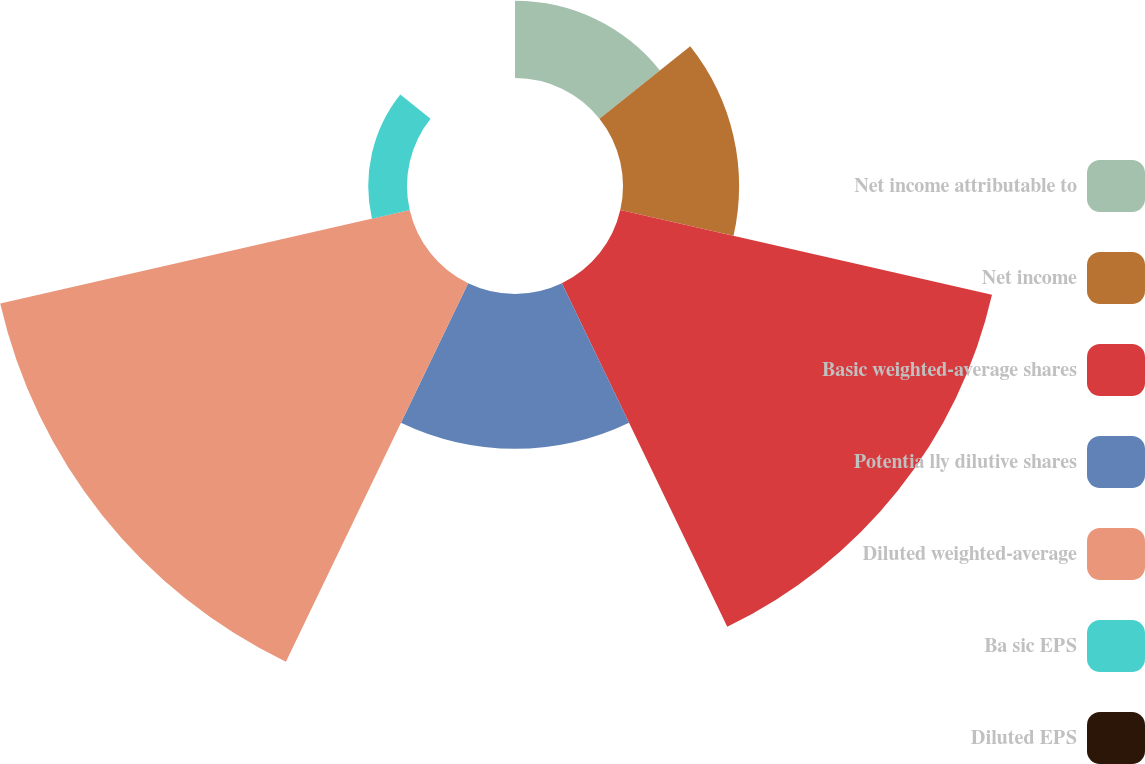Convert chart. <chart><loc_0><loc_0><loc_500><loc_500><pie_chart><fcel>Net income attributable to<fcel>Net income<fcel>Basic weighted-average shares<fcel>Potentia lly dilutive shares<fcel>Diluted weighted-average<fcel>Ba sic EPS<fcel>Diluted EPS<nl><fcel>6.51%<fcel>9.77%<fcel>32.08%<fcel>13.03%<fcel>35.34%<fcel>3.26%<fcel>0.0%<nl></chart> 